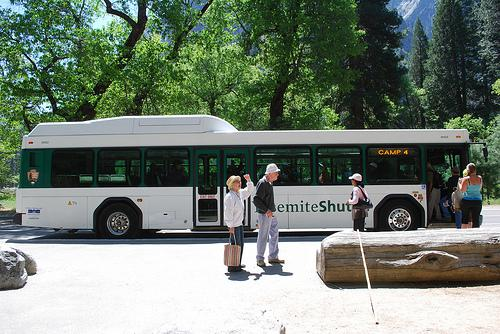Question: where was the picture taken?
Choices:
A. The sidewalk.
B. The park.
C. The side of a street.
D. The car.
Answer with the letter. Answer: C Question: what has windows?
Choices:
A. A taxi.
B. Bus.
C. A train.
D. A plane.
Answer with the letter. Answer: B Question: what is blue?
Choices:
A. Water.
B. Blue jay.
C. Sky.
D. Blueberry.
Answer with the letter. Answer: C Question: what is on the other side of the bus?
Choices:
A. The road.
B. Bus terminal.
C. Cars.
D. Trees.
Answer with the letter. Answer: D 